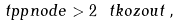<formula> <loc_0><loc_0><loc_500><loc_500>\ t p p n o d e > 2 \ t k o z o u t \, ,</formula> 